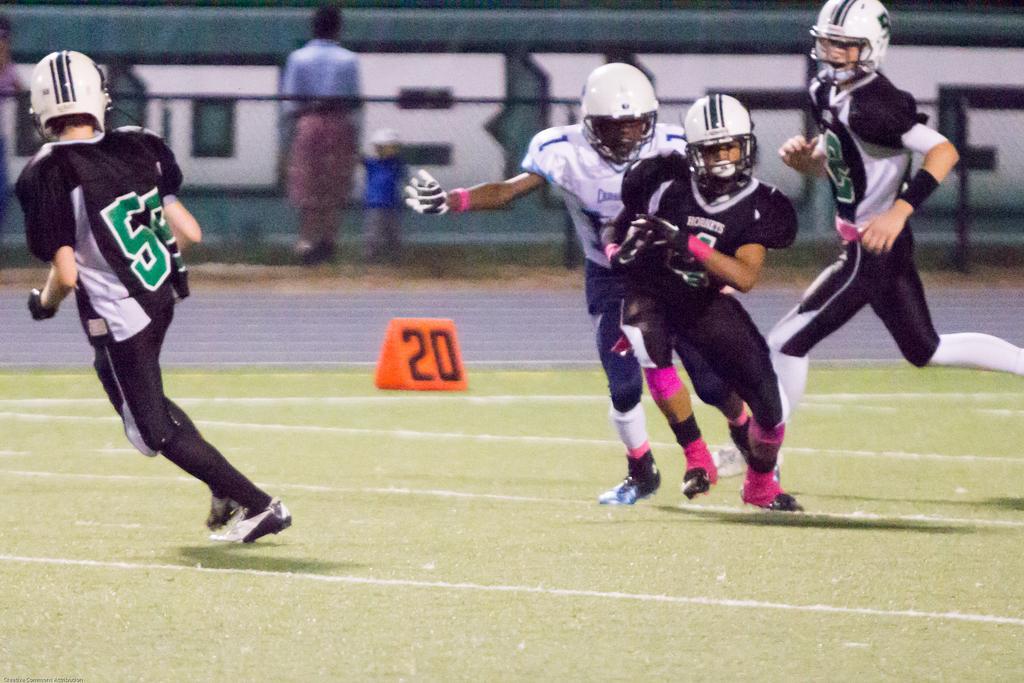How would you summarize this image in a sentence or two? In this image there is a green grass at the bottom. There are people in the foreground. There are people , poster with some text in the background. 